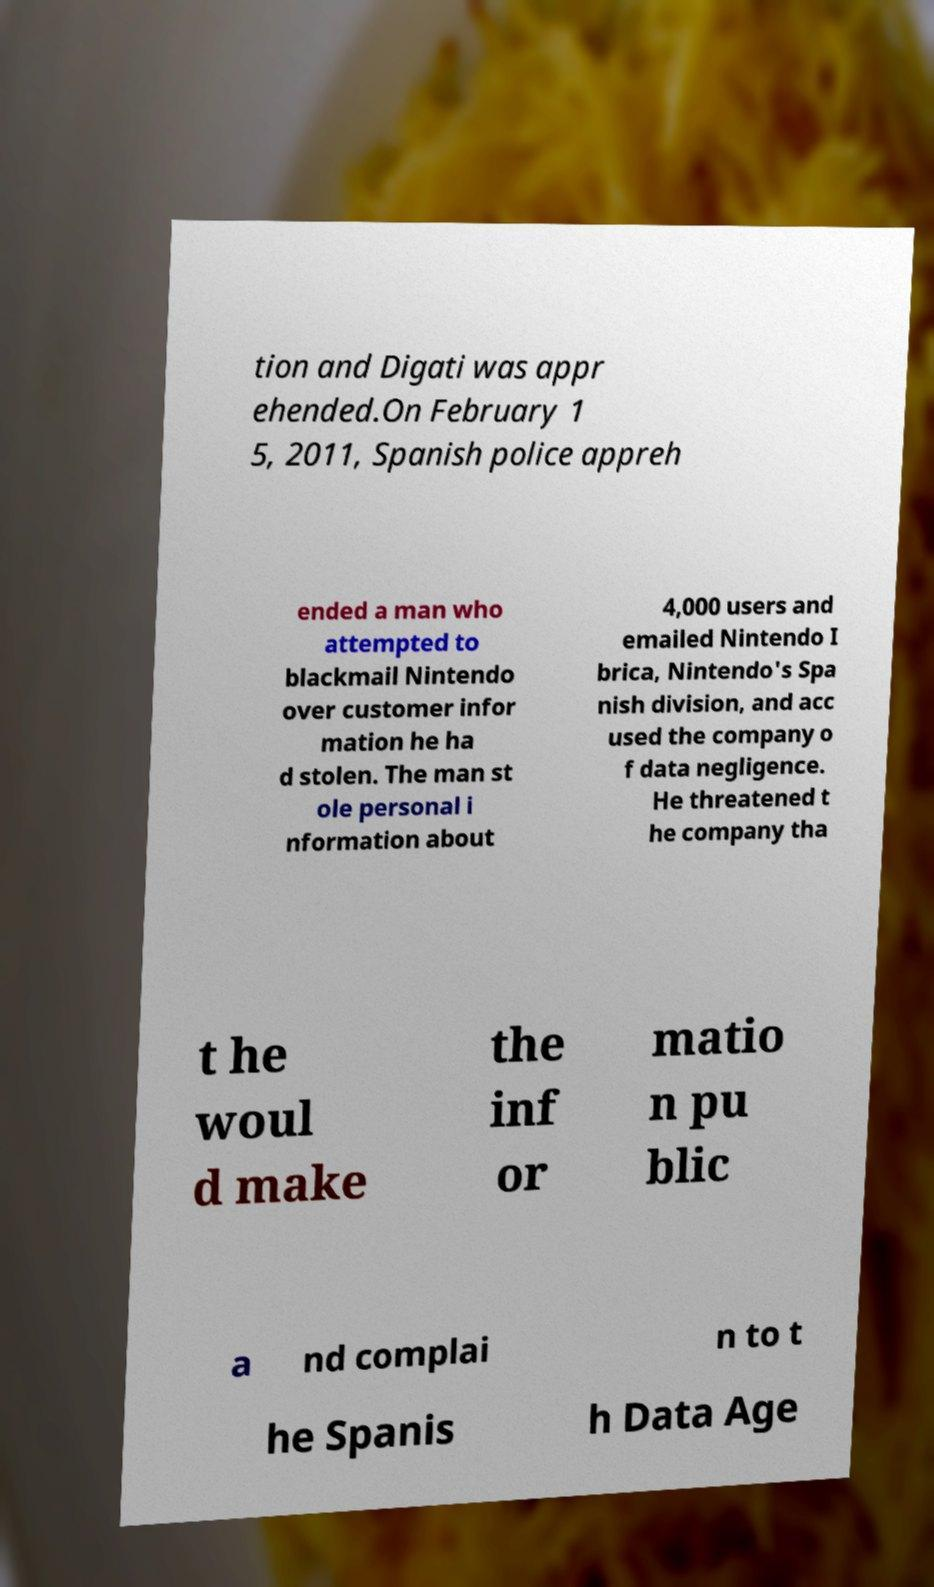Please read and relay the text visible in this image. What does it say? tion and Digati was appr ehended.On February 1 5, 2011, Spanish police appreh ended a man who attempted to blackmail Nintendo over customer infor mation he ha d stolen. The man st ole personal i nformation about 4,000 users and emailed Nintendo I brica, Nintendo's Spa nish division, and acc used the company o f data negligence. He threatened t he company tha t he woul d make the inf or matio n pu blic a nd complai n to t he Spanis h Data Age 